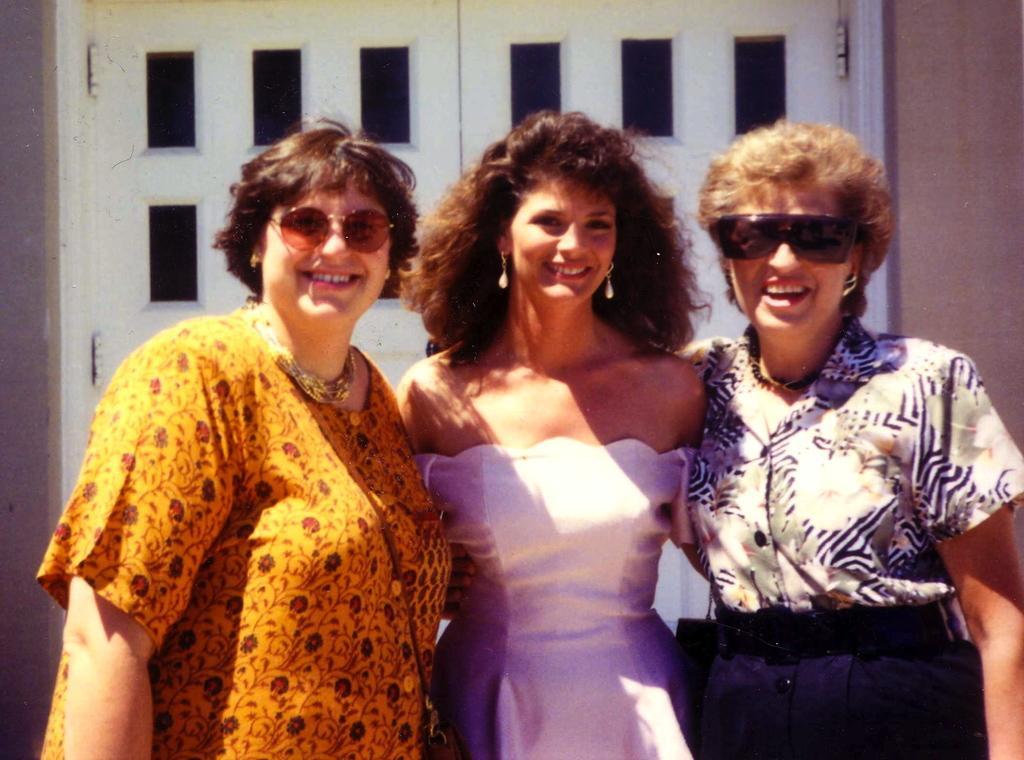How would you summarize this image in a sentence or two? In this image I can see three women standing, smiling and giving pose for the picture. In the background, I can see the wall along with the doors. 